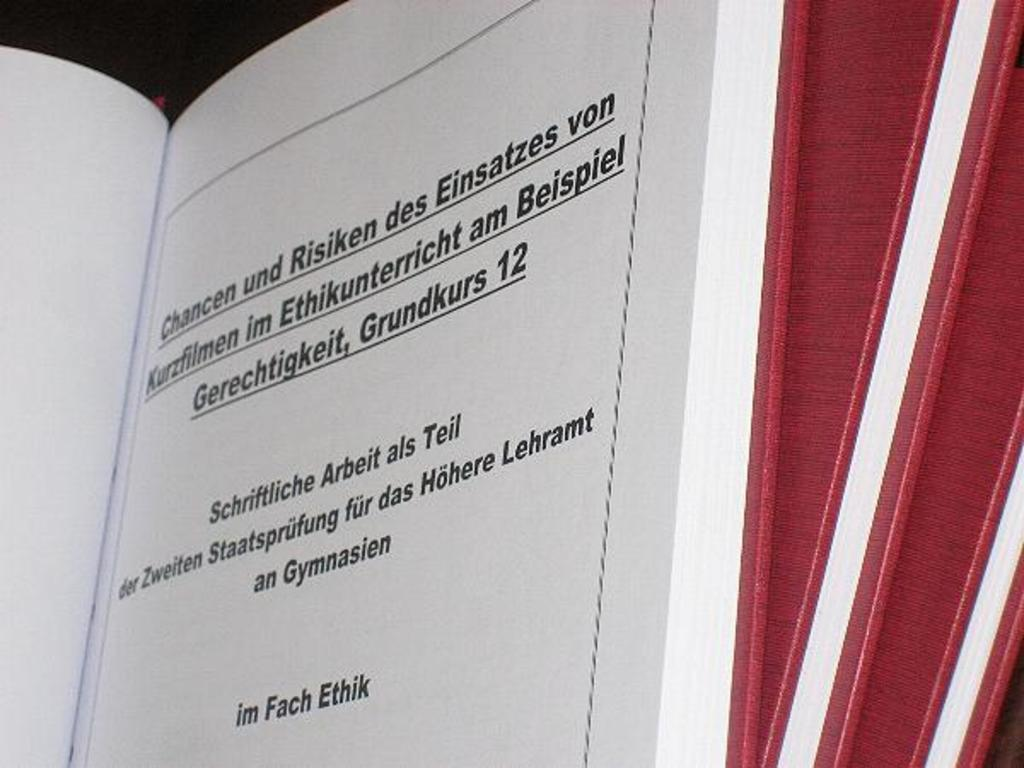Provide a one-sentence caption for the provided image. a book with German words like Chancen und Risken open. 